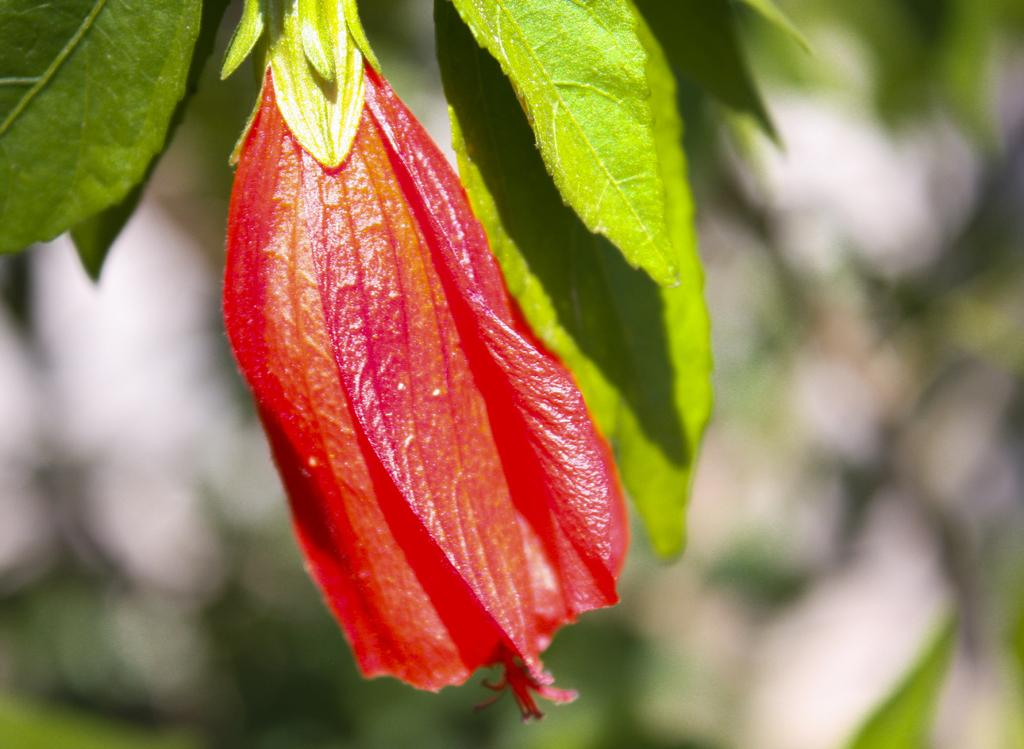What is the main subject in the front of the image? There is a flower in the front of the image. What else can be seen in the image besides the flower? There are leaves in the image. How would you describe the background of the image? The background of the image is blurry. How many pets are visible in the image? There are no pets present in the image. What type of nose can be seen on the flower in the image? Flowers do not have noses, so this detail cannot be observed in the image. 